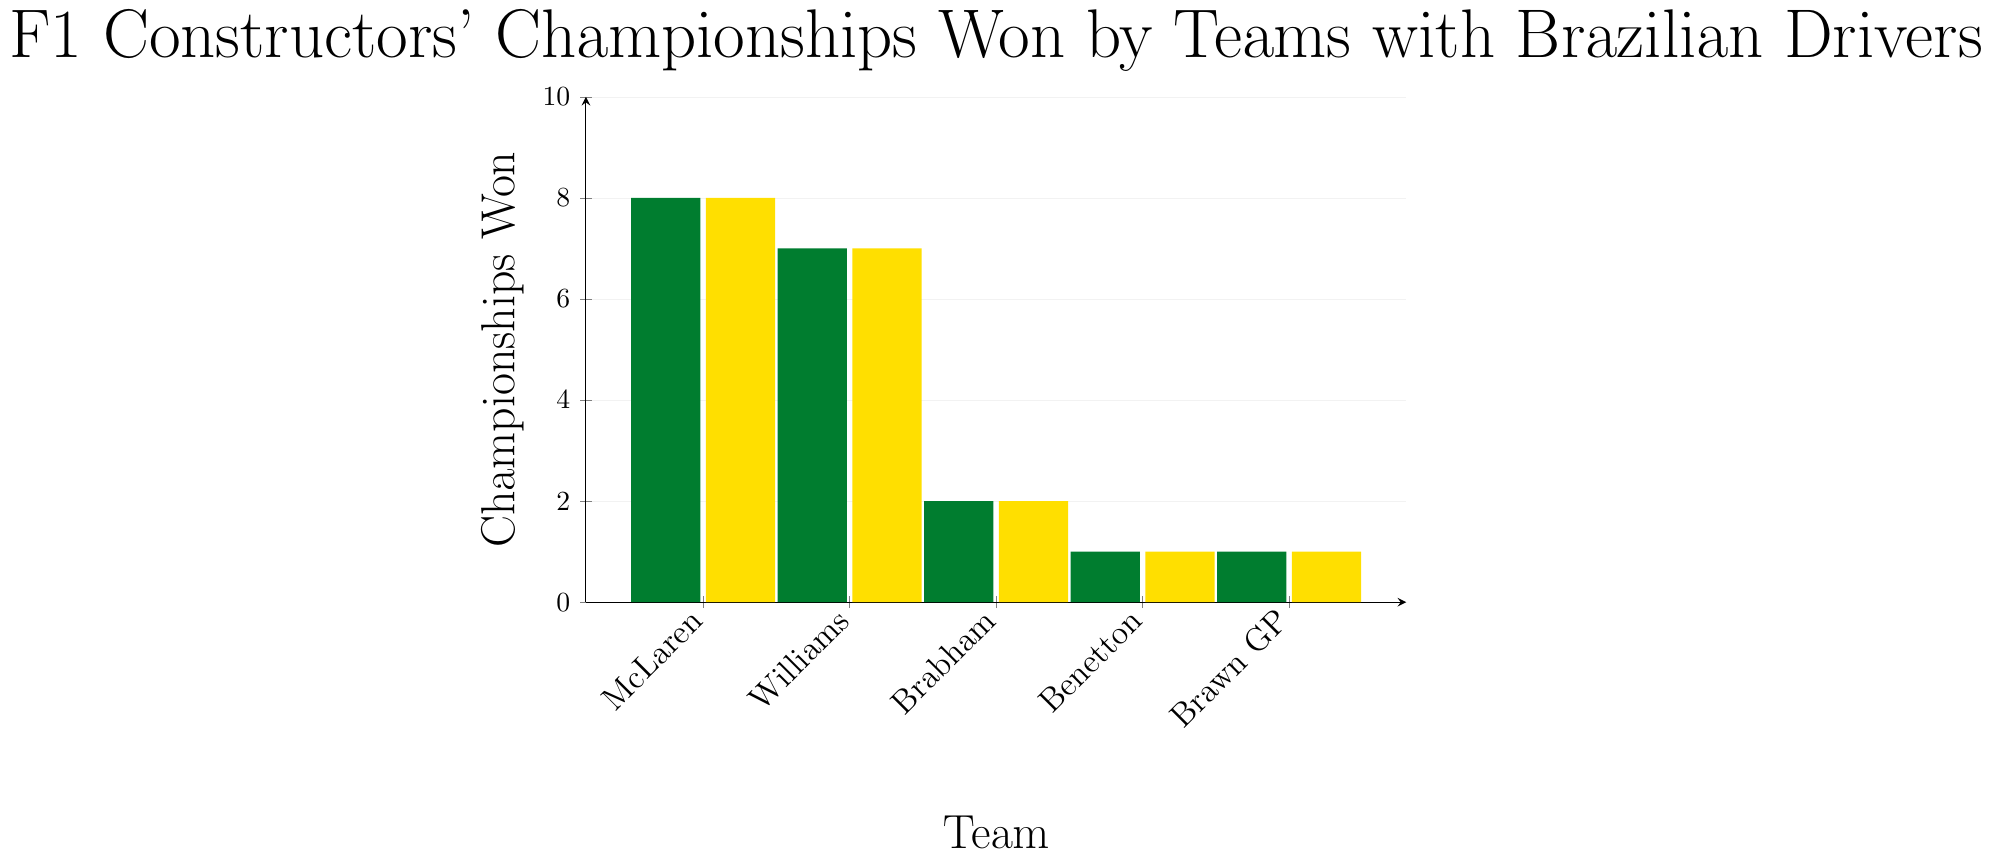Which team has won the most constructors' championships? The figure shows the number of championships each team has won. McLaren has the tallest bar, indicating they have won the most championships.
Answer: McLaren How many more championships has Williams won compared to Brabham? Williams has 7 championships and Brabham has 2. Subtract the number of championships of Brabham from Williams: 7 - 2 = 5.
Answer: 5 What is the total number of championships won by all teams combined? Sum the number of championships won by each team: McLaren (8) + Williams (7) + Brabham (2) + Benetton (1) + Brawn GP (1) = 19.
Answer: 19 Which teams have won the same number of championships? The figure shows Benetton and Brawn GP both have won 1 championship.
Answer: Benetton and Brawn GP What is the difference in championships won between the team with the most and the team with the least championships? McLaren has the most championships (8) and Benetton and Brawn GP have the least (1 each). The difference is 8 - 1 = 7.
Answer: 7 How many championships have been won by teams other than McLaren and Williams? Add the championships won by Brabham, Benetton, and Brawn GP: 2 + 1 + 1 = 4.
Answer: 4 Which team has the second-highest number of championships? The figure shows Williams has the second tallest bar with 7 championships, making them second after McLaren.
Answer: Williams If another team won 2 more championships, how would the rank of Brabham change? Adding 2 to Brabham's current 2 championships would make it 4. This would still be less than McLaren and Williams but more than Benetton and Brawn GP. Brabham would then rank third.
Answer: Third What is the average number of championships won by the teams? Sum the number of championships (19) and divide by the number of teams (5): 19 / 5 = 3.8.
Answer: 3.8 Identify the team associated with the shortest bar in the figure. The shortest bars in the figure both belong to Benetton and Brawn GP, each representing 1 championship.
Answer: Benetton and Brawn GP 